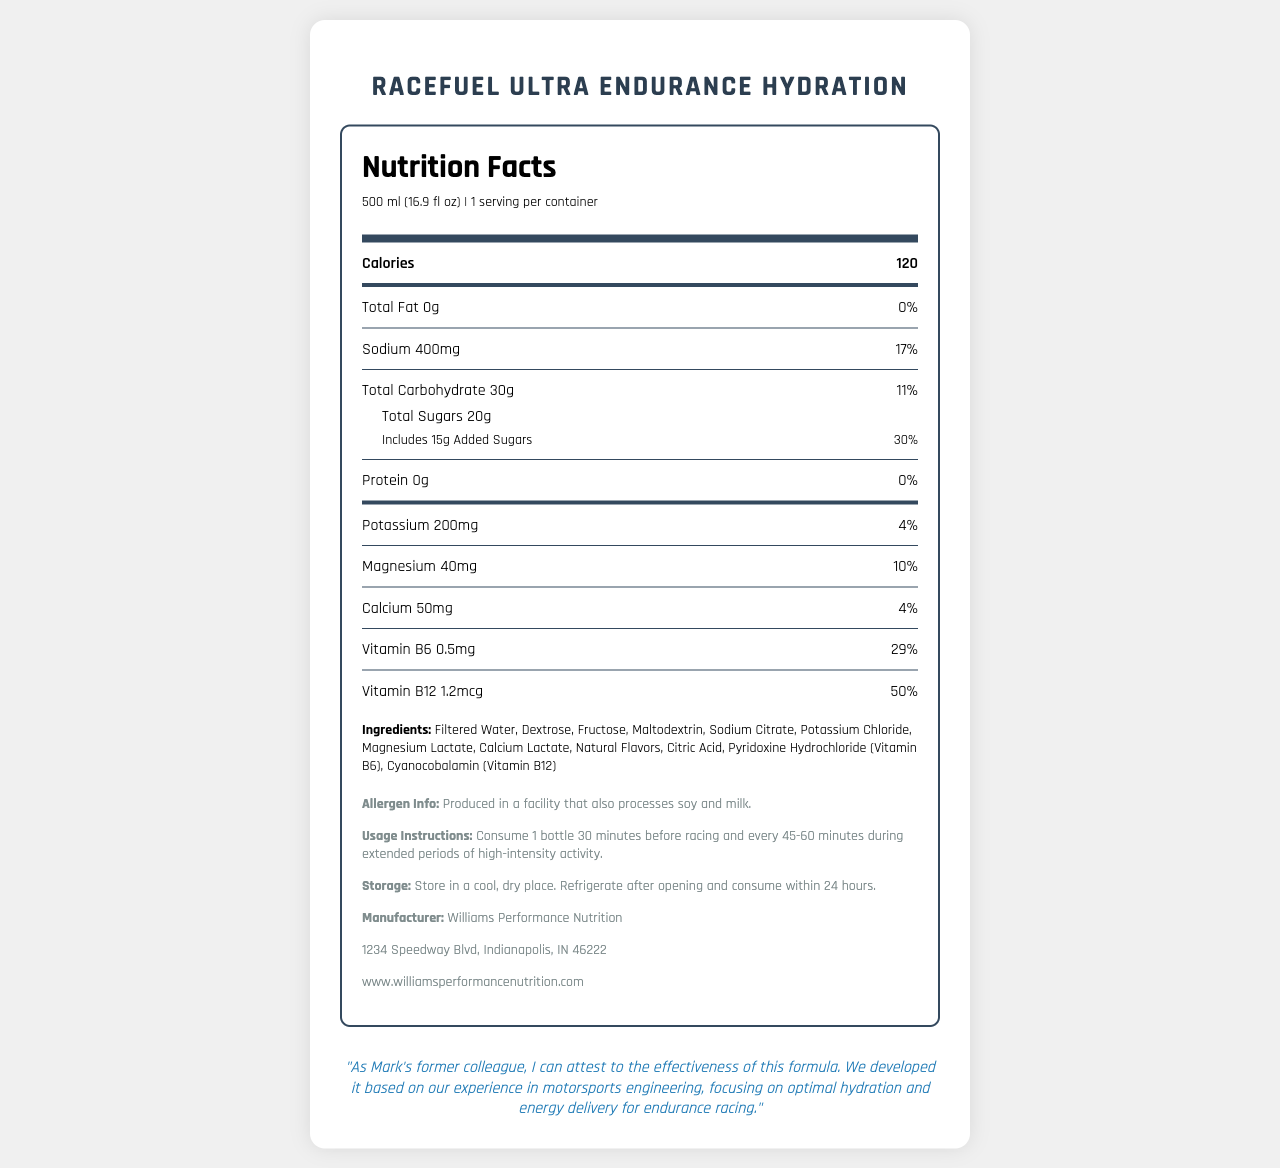what is the serving size for RaceFuel Ultra Endurance Hydration? The serving size is clearly stated at the beginning of the nutrition label.
Answer: 500 ml (16.9 fl oz) how many calories are in one serving of the drink? The document specifies that the number of calories per serving is 120.
Answer: 120 what percentage of the daily value of sodium does this drink provide? The document indicates that the drink provides 400mg of sodium, which is 17% of the daily value.
Answer: 17% does this drink contain any protein? The nutrition label shows that the drink has 0g of protein, corresponding to 0% of the daily value.
Answer: No what is the total carbohydrate content per serving? The total carbohydrate content per serving is listed as 30g in the document.
Answer: 30g what is the main source of sweeteners in this hydration drink? A. Aspartame B. High Fructose Corn Syrup C. Dextrose & Fructose D. Sucralose The ingredients list mentions dextrose and fructose as the sweeteners, making option C the correct answer.
Answer: C. Dextrose & Fructose what is the percentage of the daily value for added sugars in this drink? A. 20% B. 30% C. 40% D. 50% The drink includes 15g of added sugars, which constitutes 30% of the daily value, making B the correct answer.
Answer: B. 30% is this product suitable for someone with a soy allergy? The allergen info section indicates that the product is produced in a facility that also processes soy and milk.
Answer: It might not be suitable does the drink provide any magnesium? The nutrition label shows that it contains 40mg of magnesium, which is 10% of the daily value.
Answer: Yes describe the main idea of this document This summary captures all key aspects of the document, describing its main content and purpose.
Answer: The document provides a detailed nutrition facts label for RaceFuel Ultra Endurance Hydration, a specialized hydration drink formulated for endurance racing. It lists the nutritional content, ingredients, allergen information, usage instructions, storage instructions, manufacturer details, and includes a testimonial about the product’s effectiveness in motorsports. how many servings are in one container of RaceFuel Ultra Endurance Hydration? The nutrition label specifies that there is 1 serving per container.
Answer: 1 what is the main vitamin content in this drink for boosting endurance? The drink contains 1.2mcg of Vitamin B12, which is 50% of the daily value, making it the largest percentage among listed vitamins and potentially beneficial for endurance.
Answer: Vitamin B12 how long after opening should the drink be consumed to ensure freshness? The storage instructions state to refrigerate after opening and consume within 24 hours.
Answer: Within 24 hours where is the manufacturer of RaceFuel Ultra Endurance Hydration located? The additional info section lists this address for Williams Performance Nutrition.
Answer: 1234 Speedway Blvd, Indianapolis, IN 46222 what is the total sugar content in one serving? The document shows that total sugars in one serving amount to 20g.
Answer: 20g how should the drink be used during high-intensity activity? The usage instructions clearly state the timing and quantity of consumption.
Answer: Consume 1 bottle 30 minutes before racing and every 45-60 minutes during extended periods of high-intensity activity. what is the website for more information on the product? The additional info section at the bottom provides the website address.
Answer: www.williamsperformancenutrition.com is there information on whether this drink is gluten-free? The document does not provide any details regarding whether the drink is gluten-free or not.
Answer: Not enough information 